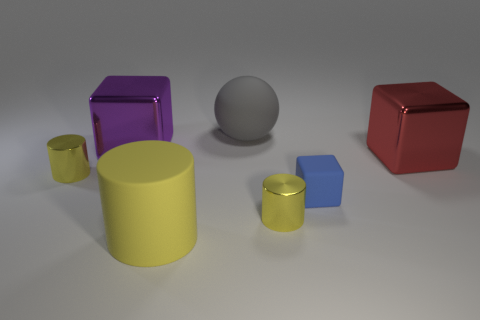What could be the potential use of these objects? The objects in the image could serve as models for educational purposes, such as teaching geometry and color recognition. They could also be part of a visual rendering test for computer graphics, illustrating how different shapes and materials react to light. Additionally, they might be props in a game where identifying colors and shapes is part of the gameplay. 